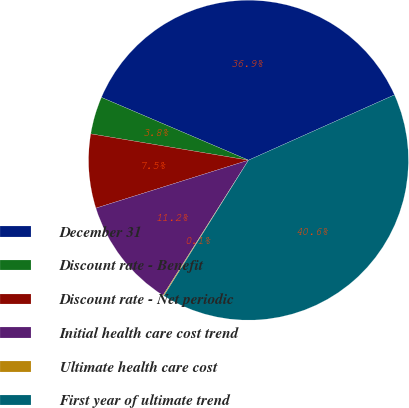Convert chart. <chart><loc_0><loc_0><loc_500><loc_500><pie_chart><fcel>December 31<fcel>Discount rate - Benefit<fcel>Discount rate - Net periodic<fcel>Initial health care cost trend<fcel>Ultimate health care cost<fcel>First year of ultimate trend<nl><fcel>36.88%<fcel>3.79%<fcel>7.48%<fcel>11.18%<fcel>0.09%<fcel>40.58%<nl></chart> 